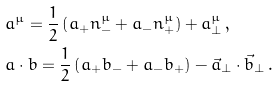<formula> <loc_0><loc_0><loc_500><loc_500>& a ^ { \mu } = \frac { 1 } { 2 } \left ( a _ { + } n _ { - } ^ { \mu } + a _ { - } n _ { + } ^ { \mu } \right ) + a _ { \bot } ^ { \mu } \, , \\ & a \cdot b = \frac { 1 } { 2 } \left ( a _ { + } b _ { - } + a _ { - } b _ { + } \right ) - \vec { a } _ { \bot } \cdot \vec { b } _ { \bot } \, .</formula> 